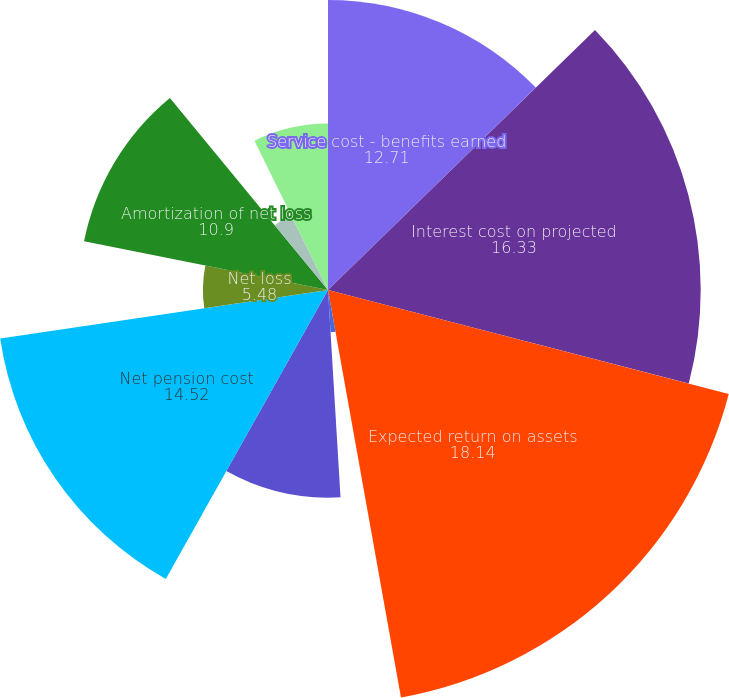<chart> <loc_0><loc_0><loc_500><loc_500><pie_chart><fcel>Service cost - benefits earned<fcel>Interest cost on projected<fcel>Expected return on assets<fcel>Amortization of prior service<fcel>Recognized net loss<fcel>Net pension cost<fcel>Net loss<fcel>Amortization of net loss<fcel>Total<fcel>Total recognized as net<nl><fcel>12.71%<fcel>16.33%<fcel>18.14%<fcel>1.86%<fcel>9.1%<fcel>14.52%<fcel>5.48%<fcel>10.9%<fcel>3.67%<fcel>7.29%<nl></chart> 